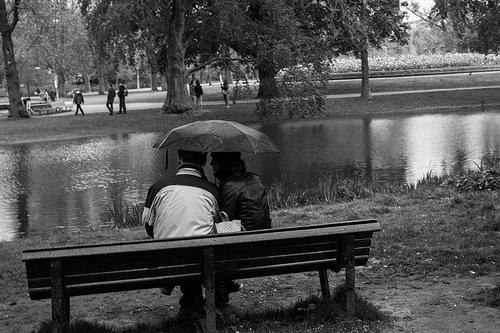Question: who is on the bench?
Choices:
A. A bird.
B. Two friends.
C. A couple in love.
D. Two people.
Answer with the letter. Answer: D Question: what is separating the groups of people?
Choices:
A. Distance.
B. Mountains.
C. Water.
D. Bad weather.
Answer with the letter. Answer: C Question: what is the bench made of?
Choices:
A. Steel.
B. Wood.
C. Metal.
D. Birch.
Answer with the letter. Answer: B 